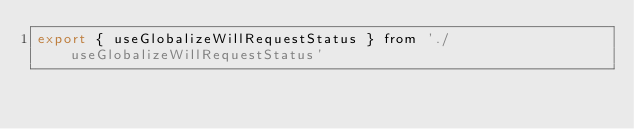Convert code to text. <code><loc_0><loc_0><loc_500><loc_500><_JavaScript_>export { useGlobalizeWillRequestStatus } from './useGlobalizeWillRequestStatus'
</code> 